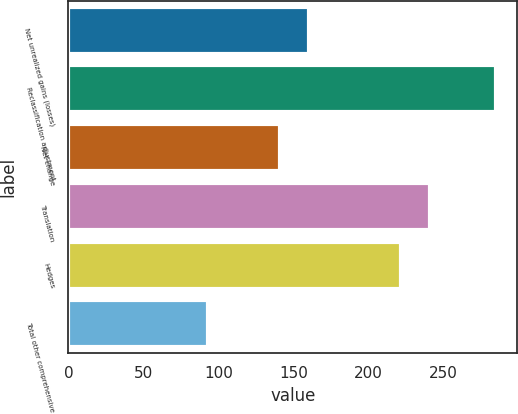Convert chart to OTSL. <chart><loc_0><loc_0><loc_500><loc_500><bar_chart><fcel>Net unrealized gains (losses)<fcel>Reclassification adjustment<fcel>Net change<fcel>Translation<fcel>Hedges<fcel>Total other comprehensive<nl><fcel>160.2<fcel>285<fcel>141<fcel>241.2<fcel>222<fcel>93<nl></chart> 